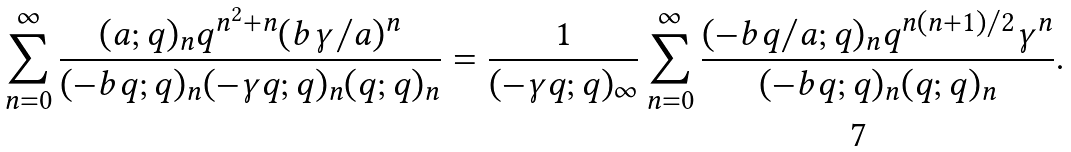<formula> <loc_0><loc_0><loc_500><loc_500>\sum _ { n = 0 } ^ { \infty } \frac { ( a ; q ) _ { n } q ^ { n ^ { 2 } + n } ( b \gamma / a ) ^ { n } } { ( - b q ; q ) _ { n } ( - \gamma q ; q ) _ { n } ( q ; q ) _ { n } } = \frac { 1 } { ( - \gamma q ; q ) _ { \infty } } \sum _ { n = 0 } ^ { \infty } \frac { ( - b q / a ; q ) _ { n } q ^ { n ( n + 1 ) / 2 } \gamma ^ { n } } { ( - b q ; q ) _ { n } ( q ; q ) _ { n } } .</formula> 